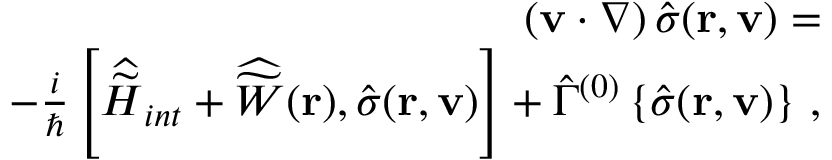Convert formula to latex. <formula><loc_0><loc_0><loc_500><loc_500>\begin{array} { r l r } & { ( { v } \cdot \nabla ) \, { \hat { \sigma } } ( { r } , { v } ) = } \\ & { - \frac { i } { } \left [ { \widehat { \widetilde { H } } } _ { i n t } + { \widehat { \widetilde { W } } } ( { r } ) , { \hat { \sigma } } ( { r } , { v } ) \right ] + { \hat { \Gamma } } ^ { ( 0 ) } \left \{ { \hat { \sigma } } ( { r } , { v } ) \right \} \, , } \end{array}</formula> 